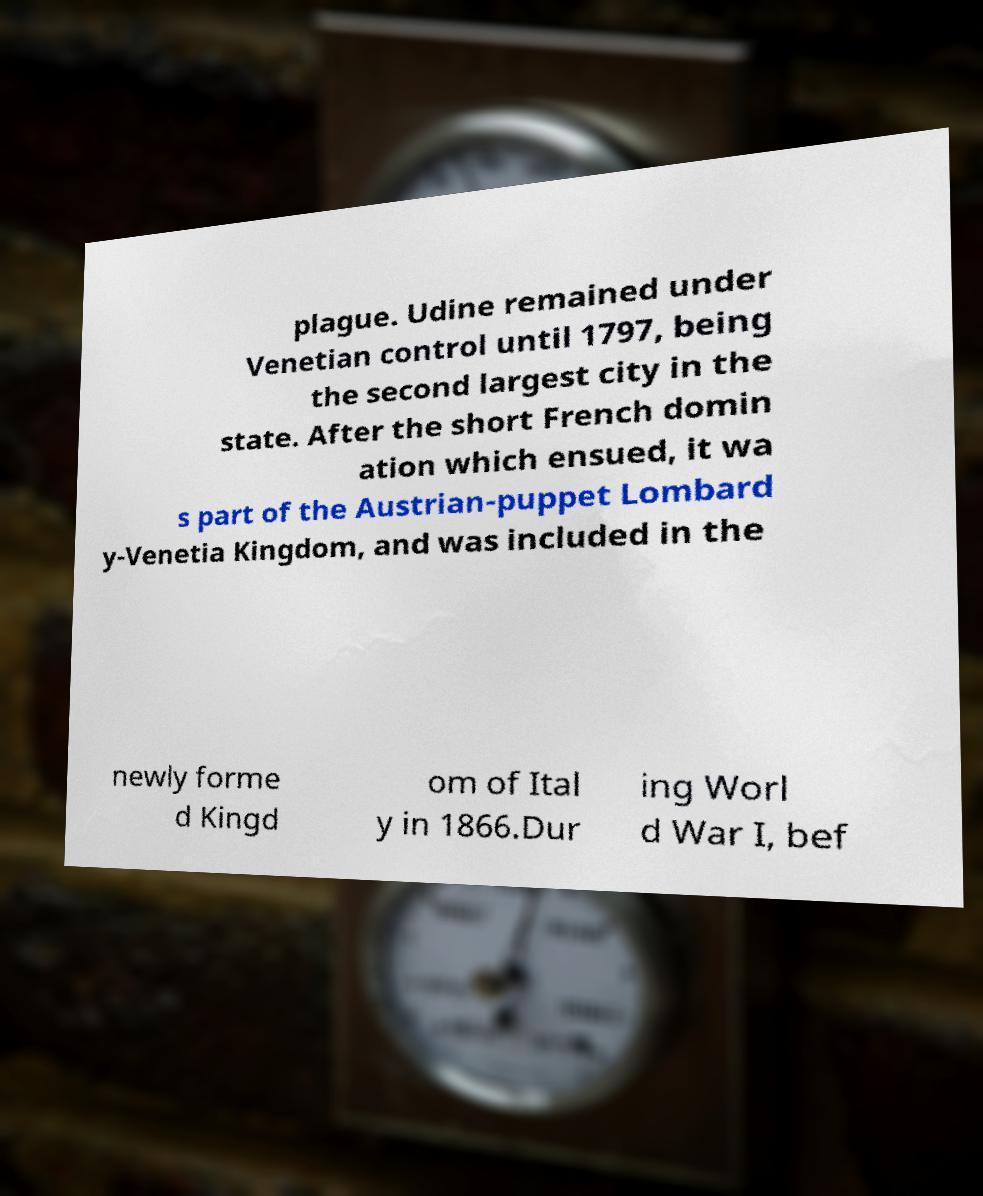I need the written content from this picture converted into text. Can you do that? plague. Udine remained under Venetian control until 1797, being the second largest city in the state. After the short French domin ation which ensued, it wa s part of the Austrian-puppet Lombard y-Venetia Kingdom, and was included in the newly forme d Kingd om of Ital y in 1866.Dur ing Worl d War I, bef 